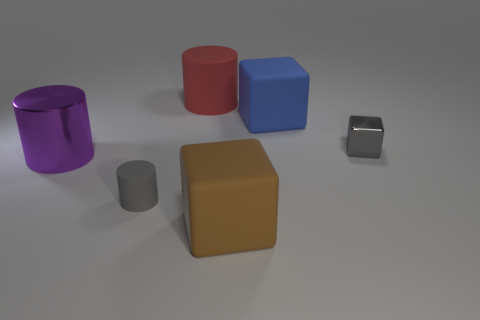There is a big cylinder that is behind the large purple thing; is its color the same as the big matte block behind the large purple metal cylinder?
Give a very brief answer. No. The block in front of the cube right of the large matte block behind the small gray metallic block is what color?
Keep it short and to the point. Brown. Is there a big purple thing that is in front of the small object to the right of the big red thing?
Give a very brief answer. Yes. Is the shape of the metal object that is behind the purple cylinder the same as  the tiny matte object?
Your answer should be very brief. No. What number of cylinders are either tiny green things or gray matte things?
Offer a terse response. 1. How many blue metal blocks are there?
Provide a succinct answer. 0. There is a block behind the gray object that is behind the tiny matte object; what is its size?
Make the answer very short. Large. How many other things are the same size as the blue matte cube?
Your answer should be very brief. 3. There is a blue matte block; how many gray things are right of it?
Your answer should be very brief. 1. What size is the gray metal block?
Provide a succinct answer. Small. 